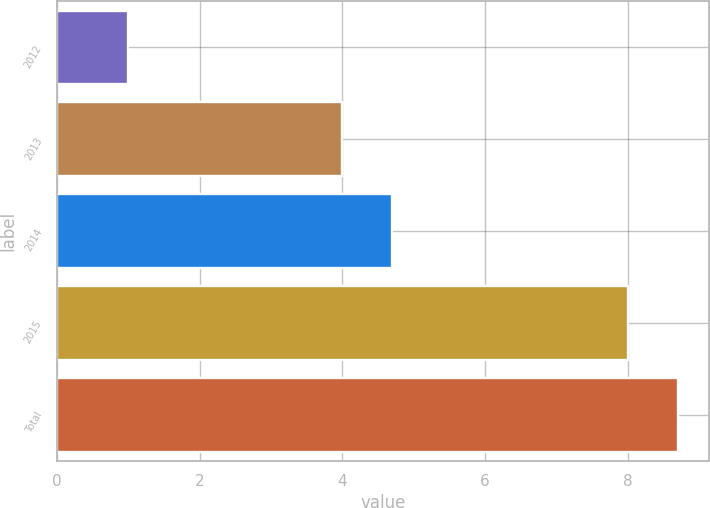<chart> <loc_0><loc_0><loc_500><loc_500><bar_chart><fcel>2012<fcel>2013<fcel>2014<fcel>2015<fcel>Total<nl><fcel>1<fcel>4<fcel>4.7<fcel>8<fcel>8.7<nl></chart> 